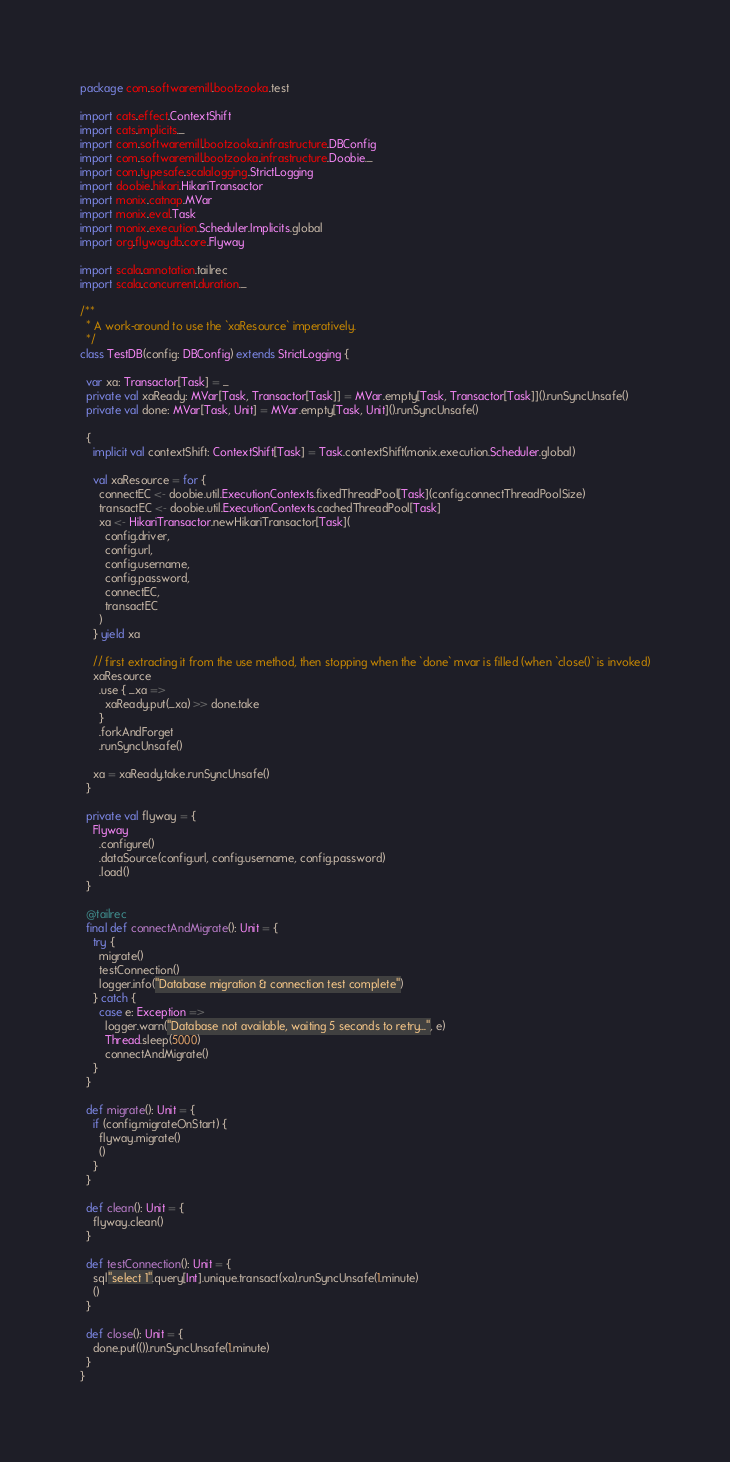Convert code to text. <code><loc_0><loc_0><loc_500><loc_500><_Scala_>package com.softwaremill.bootzooka.test

import cats.effect.ContextShift
import cats.implicits._
import com.softwaremill.bootzooka.infrastructure.DBConfig
import com.softwaremill.bootzooka.infrastructure.Doobie._
import com.typesafe.scalalogging.StrictLogging
import doobie.hikari.HikariTransactor
import monix.catnap.MVar
import monix.eval.Task
import monix.execution.Scheduler.Implicits.global
import org.flywaydb.core.Flyway

import scala.annotation.tailrec
import scala.concurrent.duration._

/**
  * A work-around to use the `xaResource` imperatively.
  */
class TestDB(config: DBConfig) extends StrictLogging {

  var xa: Transactor[Task] = _
  private val xaReady: MVar[Task, Transactor[Task]] = MVar.empty[Task, Transactor[Task]]().runSyncUnsafe()
  private val done: MVar[Task, Unit] = MVar.empty[Task, Unit]().runSyncUnsafe()

  {
    implicit val contextShift: ContextShift[Task] = Task.contextShift(monix.execution.Scheduler.global)

    val xaResource = for {
      connectEC <- doobie.util.ExecutionContexts.fixedThreadPool[Task](config.connectThreadPoolSize)
      transactEC <- doobie.util.ExecutionContexts.cachedThreadPool[Task]
      xa <- HikariTransactor.newHikariTransactor[Task](
        config.driver,
        config.url,
        config.username,
        config.password,
        connectEC,
        transactEC
      )
    } yield xa

    // first extracting it from the use method, then stopping when the `done` mvar is filled (when `close()` is invoked)
    xaResource
      .use { _xa =>
        xaReady.put(_xa) >> done.take
      }
      .forkAndForget
      .runSyncUnsafe()

    xa = xaReady.take.runSyncUnsafe()
  }

  private val flyway = {
    Flyway
      .configure()
      .dataSource(config.url, config.username, config.password)
      .load()
  }

  @tailrec
  final def connectAndMigrate(): Unit = {
    try {
      migrate()
      testConnection()
      logger.info("Database migration & connection test complete")
    } catch {
      case e: Exception =>
        logger.warn("Database not available, waiting 5 seconds to retry...", e)
        Thread.sleep(5000)
        connectAndMigrate()
    }
  }

  def migrate(): Unit = {
    if (config.migrateOnStart) {
      flyway.migrate()
      ()
    }
  }

  def clean(): Unit = {
    flyway.clean()
  }

  def testConnection(): Unit = {
    sql"select 1".query[Int].unique.transact(xa).runSyncUnsafe(1.minute)
    ()
  }

  def close(): Unit = {
    done.put(()).runSyncUnsafe(1.minute)
  }
}
</code> 